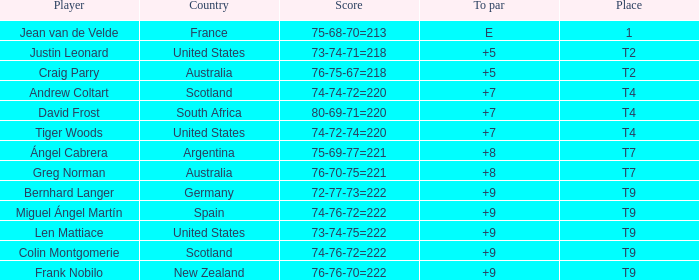Which player from the United States is in a place of T2? Justin Leonard. 